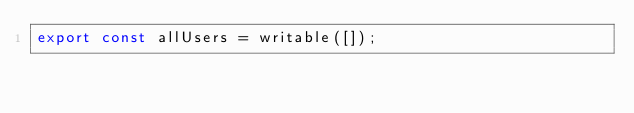Convert code to text. <code><loc_0><loc_0><loc_500><loc_500><_JavaScript_>export const allUsers = writable([]);</code> 